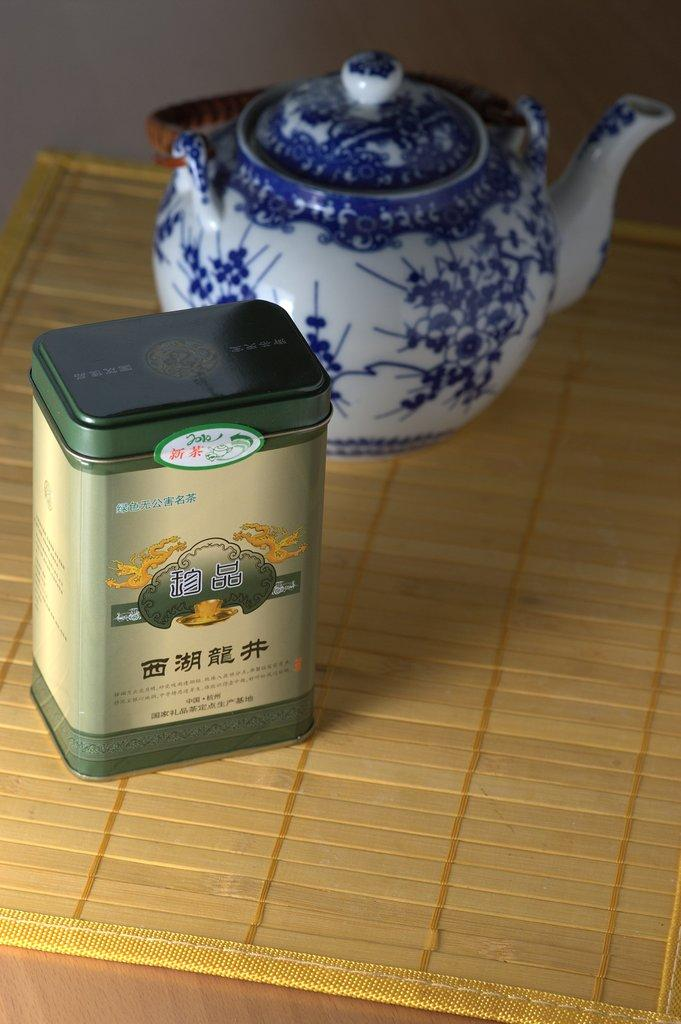What is the main object in the image? There is a kettle in the image. Can you describe the appearance of the kettle? The kettle is white and blue in color. What is located beside the kettle? There is a box beside the kettle. What can be seen on the box? The box has something written on it. On what object are the kettle and box placed? The kettle and box are placed on an object. Can you tell me how many flowers are growing in the field behind the kettle? There is no field or flowers present in the image; it only features a kettle and a box. What type of trousers is the person wearing while holding the kettle? There is no person present in the image, so it is not possible to determine what type of trousers they might be wearing. 